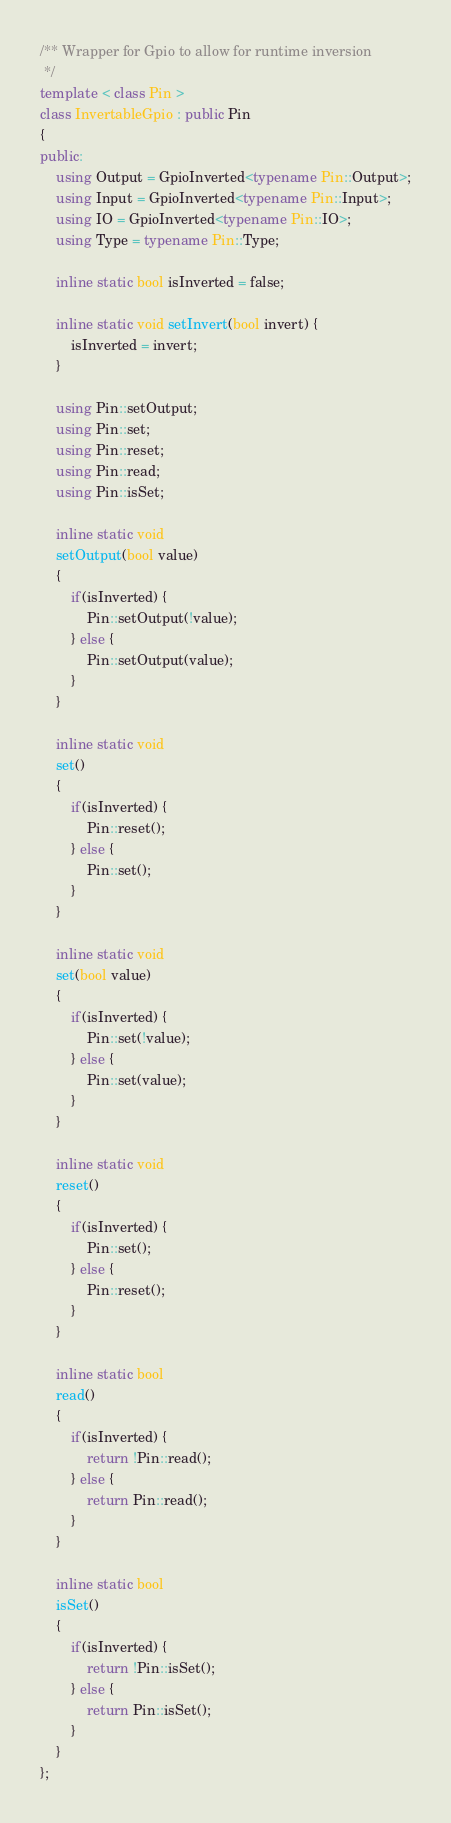<code> <loc_0><loc_0><loc_500><loc_500><_C++_>/** Wrapper for Gpio to allow for runtime inversion
 */
template < class Pin >
class InvertableGpio : public Pin
{
public:
	using Output = GpioInverted<typename Pin::Output>;
	using Input = GpioInverted<typename Pin::Input>;
	using IO = GpioInverted<typename Pin::IO>;
	using Type = typename Pin::Type;
	
    inline static bool isInverted = false;

    inline static void setInvert(bool invert) {
        isInverted = invert;
    }

	using Pin::setOutput;
	using Pin::set;
	using Pin::reset;
	using Pin::read;
	using Pin::isSet;

	inline static void
	setOutput(bool value)
	{
        if(isInverted) {
		    Pin::setOutput(!value);
        } else {
            Pin::setOutput(value);
        }
	}

	inline static void
	set()
	{
        if(isInverted) {
		    Pin::reset();
        } else {
            Pin::set();
        }
	}

	inline static void
	set(bool value)
	{
        if(isInverted) {
		    Pin::set(!value);
        } else {
            Pin::set(value);
        }
	}

	inline static void
	reset()
	{
        if(isInverted) {
		    Pin::set();
        } else {
            Pin::reset();
        }
	}

	inline static bool
	read()
	{
        if(isInverted) {
		    return !Pin::read();
        } else {
            return Pin::read();
        }
	}

	inline static bool
	isSet()
	{
        if(isInverted) {
		    return !Pin::isSet();
        } else {
            return Pin::isSet();
        }
	}
};
</code> 